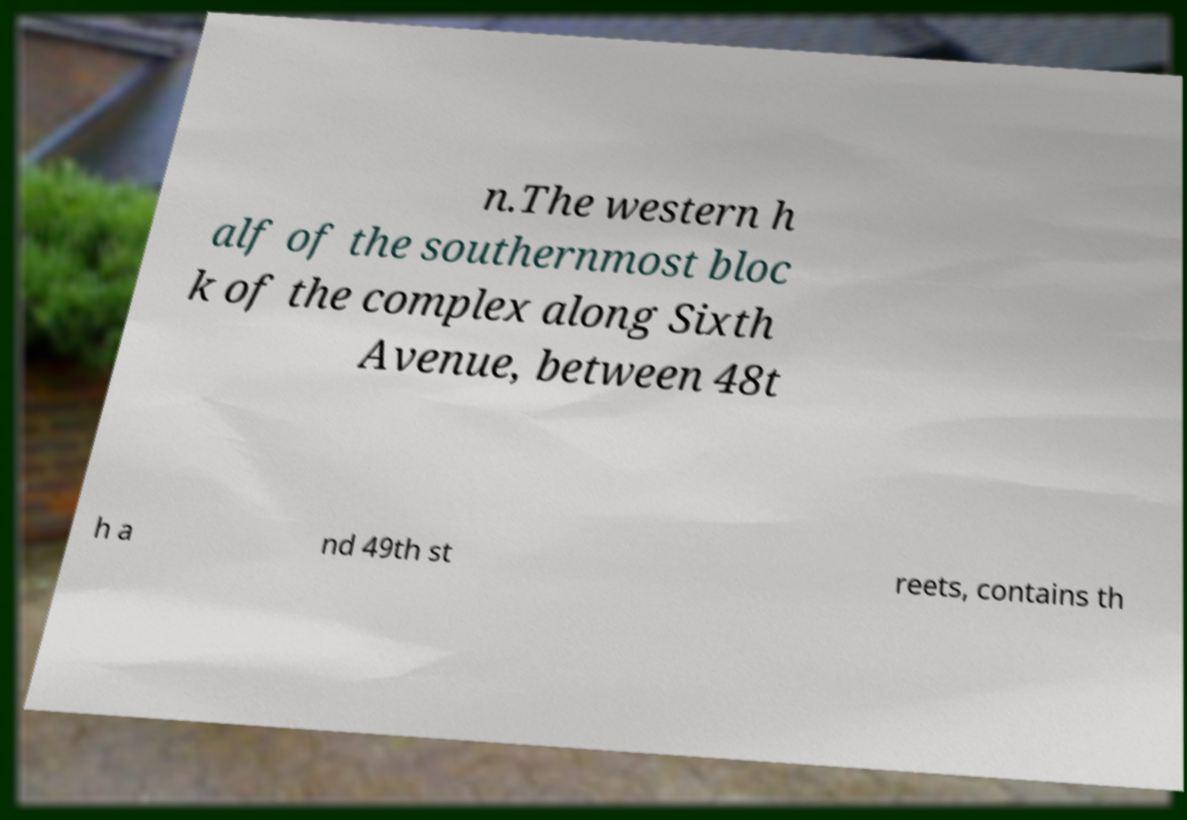Could you assist in decoding the text presented in this image and type it out clearly? n.The western h alf of the southernmost bloc k of the complex along Sixth Avenue, between 48t h a nd 49th st reets, contains th 